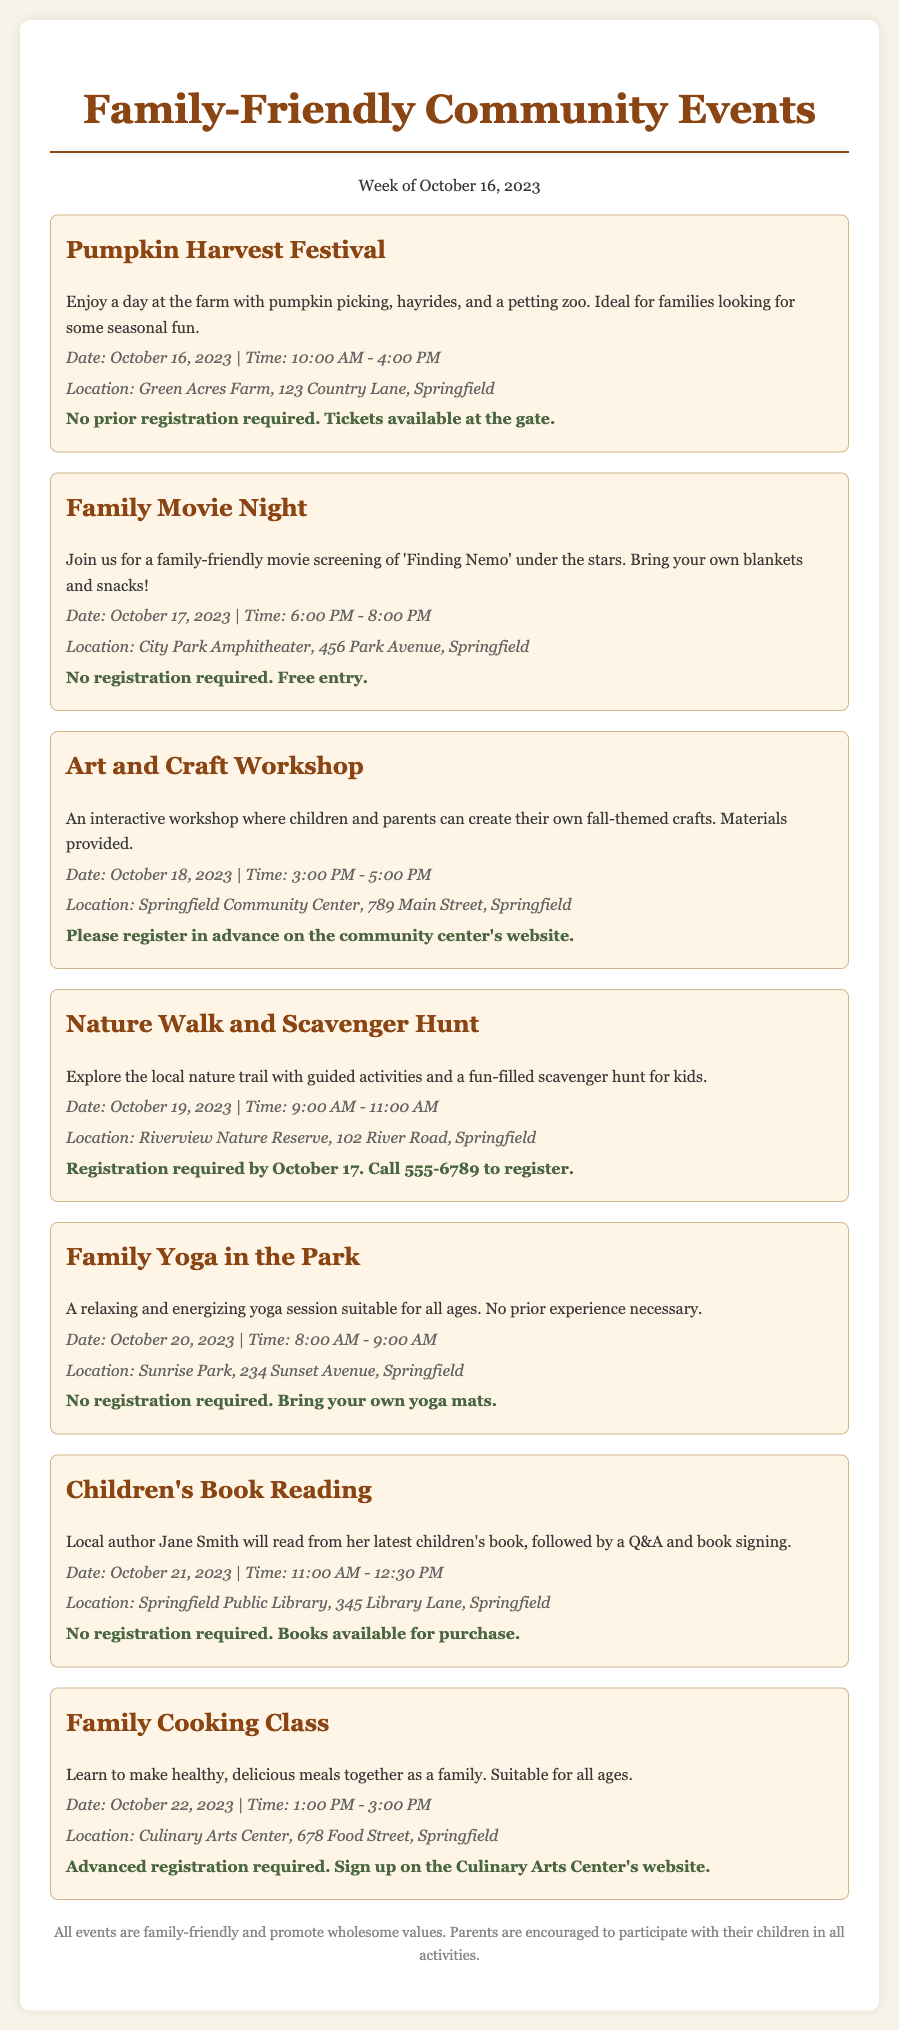What is the date of the Pumpkin Harvest Festival? The date is mentioned under the event details for the Pumpkin Harvest Festival.
Answer: October 16, 2023 Where is the Family Movie Night taking place? The location for the Family Movie Night is provided in the event details.
Answer: City Park Amphitheater, 456 Park Avenue, Springfield What time does the Art and Craft Workshop start? The starting time for the Art and Craft Workshop is included in the event details.
Answer: 3:00 PM Is registration required for the Nature Walk and Scavenger Hunt? The registration requirement is mentioned for this event in the details section.
Answer: Yes Which event allows for purchasing books? The event that mentions books available for purchase is specified in the description.
Answer: Children's Book Reading What type of activities are included in the Pumpkin Harvest Festival? The activities are listed in the description of the event.
Answer: Pumpkin picking, hayrides, petting zoo How many events are scheduled for October 20, 2023? This information can be indirectly inferred by counting the events listed for that date in the document.
Answer: One What is the focus of the Family Cooking Class? The focus is outlined in the description of the Family Cooking Class event.
Answer: Healthy, delicious meals What should participants bring for Yoga in the Park? The requirement is stated in the event details for Family Yoga in the Park.
Answer: Yoga mats 